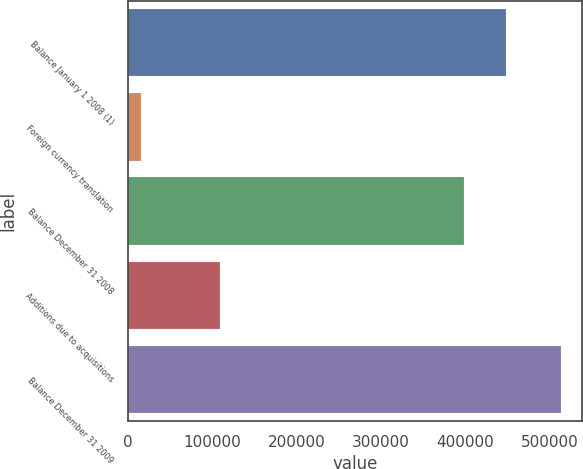Convert chart to OTSL. <chart><loc_0><loc_0><loc_500><loc_500><bar_chart><fcel>Balance January 1 2008 (1)<fcel>Foreign currency translation<fcel>Balance December 31 2008<fcel>Additions due to acquisitions<fcel>Balance December 31 2009<nl><fcel>448590<fcel>15084<fcel>398737<fcel>108982<fcel>513612<nl></chart> 